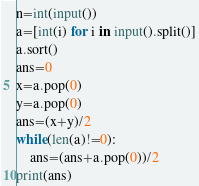<code> <loc_0><loc_0><loc_500><loc_500><_Python_>n=int(input())
a=[int(i) for i in input().split()]
a.sort()
ans=0
x=a.pop(0)
y=a.pop(0)
ans=(x+y)/2
while(len(a)!=0):
    ans=(ans+a.pop(0))/2
print(ans)</code> 